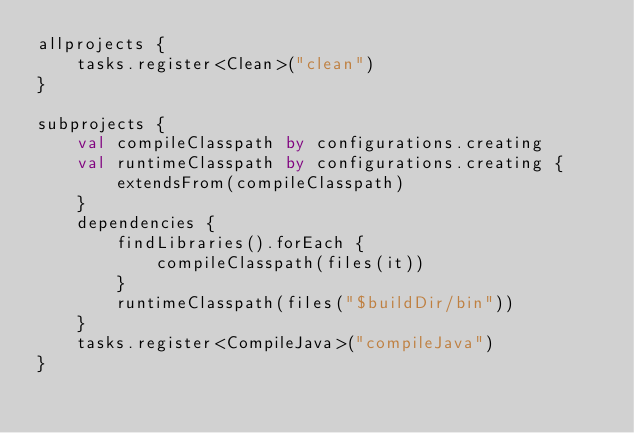Convert code to text. <code><loc_0><loc_0><loc_500><loc_500><_Kotlin_>allprojects {
    tasks.register<Clean>("clean")
}

subprojects {
    val compileClasspath by configurations.creating
    val runtimeClasspath by configurations.creating {
        extendsFrom(compileClasspath)
    }
    dependencies {
        findLibraries().forEach {
            compileClasspath(files(it))
        }
        runtimeClasspath(files("$buildDir/bin"))
    }
    tasks.register<CompileJava>("compileJava")
}
</code> 